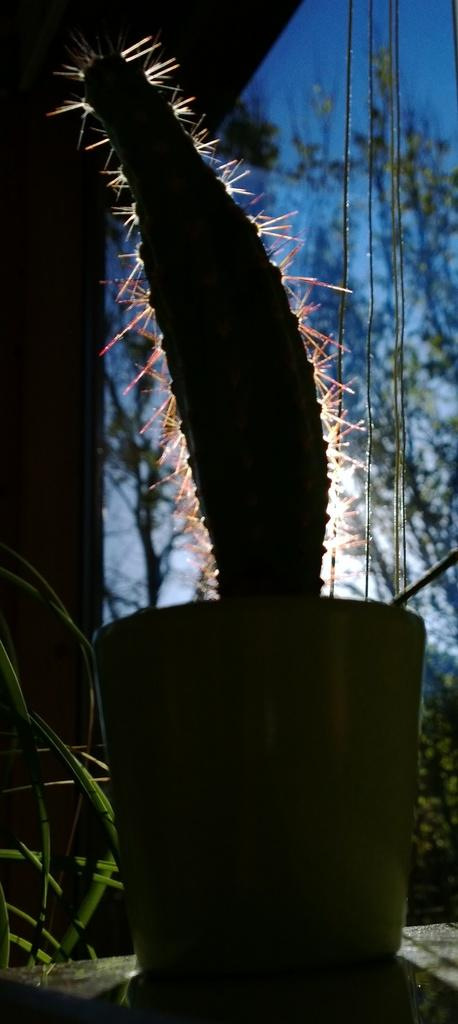What type of plant is in the image? There is a cactus plant in the image. How is the cactus plant contained in the image? The cactus plant is kept in a pot. What type of soda is being compared to the cactus plant in the image? There is no soda present in the image, nor is there any comparison being made between the cactus plant and a soda. 